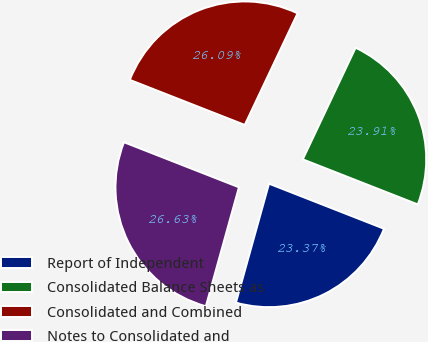Convert chart to OTSL. <chart><loc_0><loc_0><loc_500><loc_500><pie_chart><fcel>Report of Independent<fcel>Consolidated Balance Sheets as<fcel>Consolidated and Combined<fcel>Notes to Consolidated and<nl><fcel>23.37%<fcel>23.91%<fcel>26.09%<fcel>26.63%<nl></chart> 